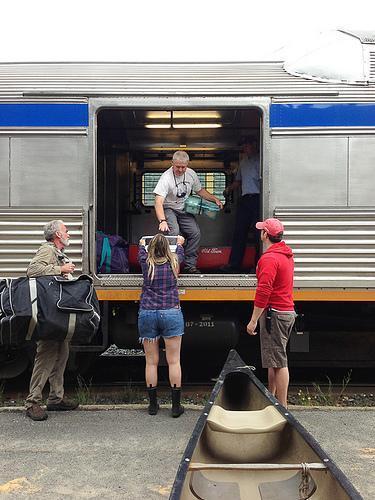How many people are in the photo?
Give a very brief answer. 5. 